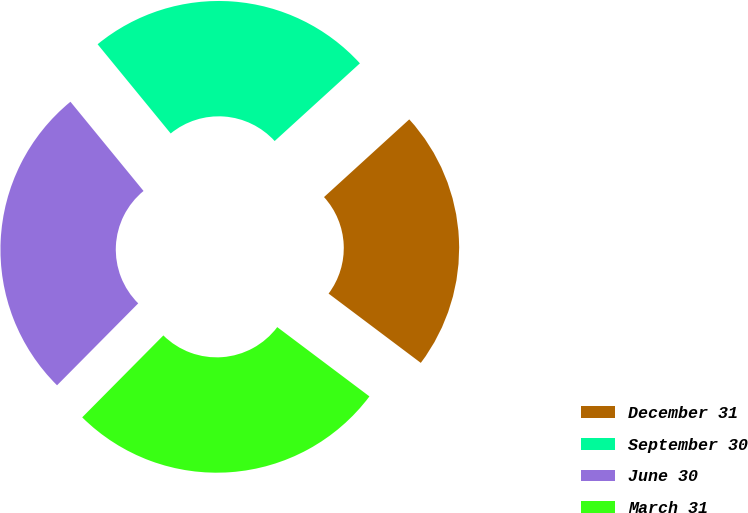Convert chart to OTSL. <chart><loc_0><loc_0><loc_500><loc_500><pie_chart><fcel>December 31<fcel>September 30<fcel>June 30<fcel>March 31<nl><fcel>22.02%<fcel>24.16%<fcel>26.65%<fcel>27.17%<nl></chart> 